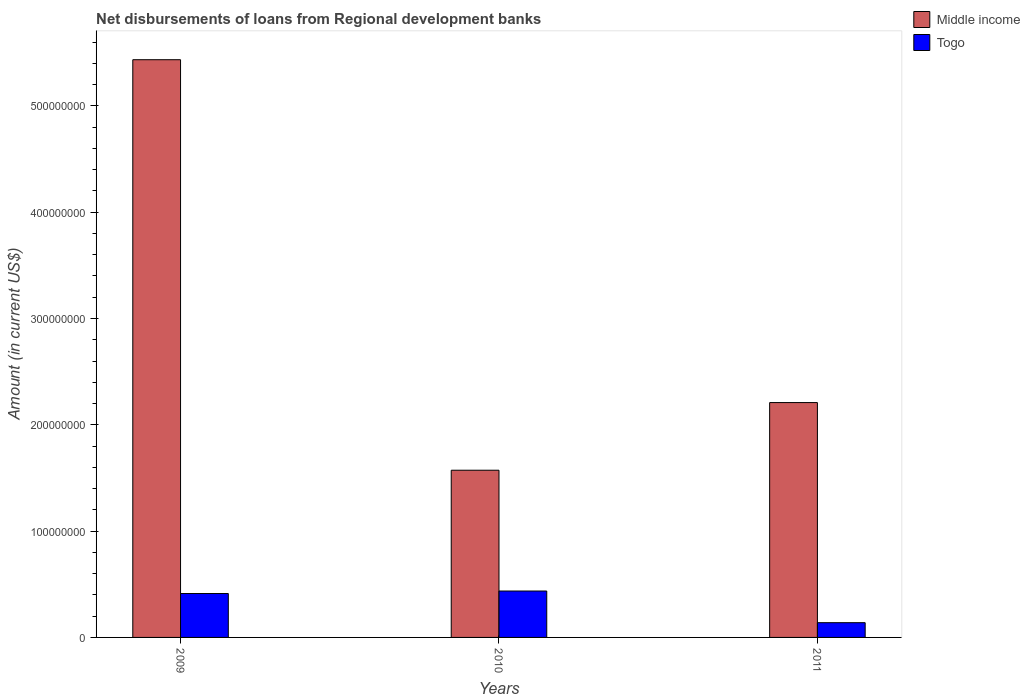How many groups of bars are there?
Ensure brevity in your answer.  3. Are the number of bars per tick equal to the number of legend labels?
Keep it short and to the point. Yes. Are the number of bars on each tick of the X-axis equal?
Make the answer very short. Yes. How many bars are there on the 3rd tick from the right?
Your response must be concise. 2. What is the amount of disbursements of loans from regional development banks in Togo in 2010?
Give a very brief answer. 4.36e+07. Across all years, what is the maximum amount of disbursements of loans from regional development banks in Togo?
Keep it short and to the point. 4.36e+07. Across all years, what is the minimum amount of disbursements of loans from regional development banks in Togo?
Keep it short and to the point. 1.39e+07. In which year was the amount of disbursements of loans from regional development banks in Middle income maximum?
Give a very brief answer. 2009. In which year was the amount of disbursements of loans from regional development banks in Togo minimum?
Give a very brief answer. 2011. What is the total amount of disbursements of loans from regional development banks in Togo in the graph?
Keep it short and to the point. 9.88e+07. What is the difference between the amount of disbursements of loans from regional development banks in Middle income in 2009 and that in 2010?
Keep it short and to the point. 3.86e+08. What is the difference between the amount of disbursements of loans from regional development banks in Togo in 2011 and the amount of disbursements of loans from regional development banks in Middle income in 2009?
Provide a short and direct response. -5.30e+08. What is the average amount of disbursements of loans from regional development banks in Middle income per year?
Give a very brief answer. 3.07e+08. In the year 2011, what is the difference between the amount of disbursements of loans from regional development banks in Togo and amount of disbursements of loans from regional development banks in Middle income?
Provide a succinct answer. -2.07e+08. What is the ratio of the amount of disbursements of loans from regional development banks in Togo in 2009 to that in 2011?
Provide a short and direct response. 2.98. What is the difference between the highest and the second highest amount of disbursements of loans from regional development banks in Togo?
Ensure brevity in your answer.  2.34e+06. What is the difference between the highest and the lowest amount of disbursements of loans from regional development banks in Middle income?
Offer a terse response. 3.86e+08. What does the 1st bar from the right in 2009 represents?
Your answer should be compact. Togo. How many bars are there?
Give a very brief answer. 6. How many years are there in the graph?
Offer a terse response. 3. What is the difference between two consecutive major ticks on the Y-axis?
Provide a short and direct response. 1.00e+08. Are the values on the major ticks of Y-axis written in scientific E-notation?
Ensure brevity in your answer.  No. Does the graph contain any zero values?
Provide a succinct answer. No. Where does the legend appear in the graph?
Your response must be concise. Top right. How many legend labels are there?
Offer a very short reply. 2. What is the title of the graph?
Make the answer very short. Net disbursements of loans from Regional development banks. Does "Latin America(developing only)" appear as one of the legend labels in the graph?
Ensure brevity in your answer.  No. What is the label or title of the Y-axis?
Offer a terse response. Amount (in current US$). What is the Amount (in current US$) of Middle income in 2009?
Your response must be concise. 5.43e+08. What is the Amount (in current US$) of Togo in 2009?
Your response must be concise. 4.13e+07. What is the Amount (in current US$) of Middle income in 2010?
Give a very brief answer. 1.57e+08. What is the Amount (in current US$) in Togo in 2010?
Provide a succinct answer. 4.36e+07. What is the Amount (in current US$) of Middle income in 2011?
Your answer should be compact. 2.21e+08. What is the Amount (in current US$) of Togo in 2011?
Offer a terse response. 1.39e+07. Across all years, what is the maximum Amount (in current US$) in Middle income?
Your answer should be compact. 5.43e+08. Across all years, what is the maximum Amount (in current US$) in Togo?
Offer a terse response. 4.36e+07. Across all years, what is the minimum Amount (in current US$) of Middle income?
Your response must be concise. 1.57e+08. Across all years, what is the minimum Amount (in current US$) in Togo?
Provide a succinct answer. 1.39e+07. What is the total Amount (in current US$) of Middle income in the graph?
Provide a short and direct response. 9.22e+08. What is the total Amount (in current US$) in Togo in the graph?
Provide a succinct answer. 9.88e+07. What is the difference between the Amount (in current US$) in Middle income in 2009 and that in 2010?
Your response must be concise. 3.86e+08. What is the difference between the Amount (in current US$) in Togo in 2009 and that in 2010?
Keep it short and to the point. -2.34e+06. What is the difference between the Amount (in current US$) in Middle income in 2009 and that in 2011?
Make the answer very short. 3.22e+08. What is the difference between the Amount (in current US$) in Togo in 2009 and that in 2011?
Provide a succinct answer. 2.74e+07. What is the difference between the Amount (in current US$) in Middle income in 2010 and that in 2011?
Make the answer very short. -6.36e+07. What is the difference between the Amount (in current US$) in Togo in 2010 and that in 2011?
Keep it short and to the point. 2.98e+07. What is the difference between the Amount (in current US$) of Middle income in 2009 and the Amount (in current US$) of Togo in 2010?
Your response must be concise. 5.00e+08. What is the difference between the Amount (in current US$) in Middle income in 2009 and the Amount (in current US$) in Togo in 2011?
Make the answer very short. 5.30e+08. What is the difference between the Amount (in current US$) of Middle income in 2010 and the Amount (in current US$) of Togo in 2011?
Provide a succinct answer. 1.43e+08. What is the average Amount (in current US$) of Middle income per year?
Give a very brief answer. 3.07e+08. What is the average Amount (in current US$) in Togo per year?
Provide a succinct answer. 3.29e+07. In the year 2009, what is the difference between the Amount (in current US$) of Middle income and Amount (in current US$) of Togo?
Provide a succinct answer. 5.02e+08. In the year 2010, what is the difference between the Amount (in current US$) of Middle income and Amount (in current US$) of Togo?
Your answer should be very brief. 1.14e+08. In the year 2011, what is the difference between the Amount (in current US$) in Middle income and Amount (in current US$) in Togo?
Provide a succinct answer. 2.07e+08. What is the ratio of the Amount (in current US$) of Middle income in 2009 to that in 2010?
Provide a short and direct response. 3.46. What is the ratio of the Amount (in current US$) of Togo in 2009 to that in 2010?
Ensure brevity in your answer.  0.95. What is the ratio of the Amount (in current US$) in Middle income in 2009 to that in 2011?
Make the answer very short. 2.46. What is the ratio of the Amount (in current US$) of Togo in 2009 to that in 2011?
Ensure brevity in your answer.  2.98. What is the ratio of the Amount (in current US$) of Middle income in 2010 to that in 2011?
Offer a terse response. 0.71. What is the ratio of the Amount (in current US$) of Togo in 2010 to that in 2011?
Your response must be concise. 3.15. What is the difference between the highest and the second highest Amount (in current US$) of Middle income?
Ensure brevity in your answer.  3.22e+08. What is the difference between the highest and the second highest Amount (in current US$) in Togo?
Your answer should be compact. 2.34e+06. What is the difference between the highest and the lowest Amount (in current US$) of Middle income?
Your answer should be compact. 3.86e+08. What is the difference between the highest and the lowest Amount (in current US$) in Togo?
Keep it short and to the point. 2.98e+07. 